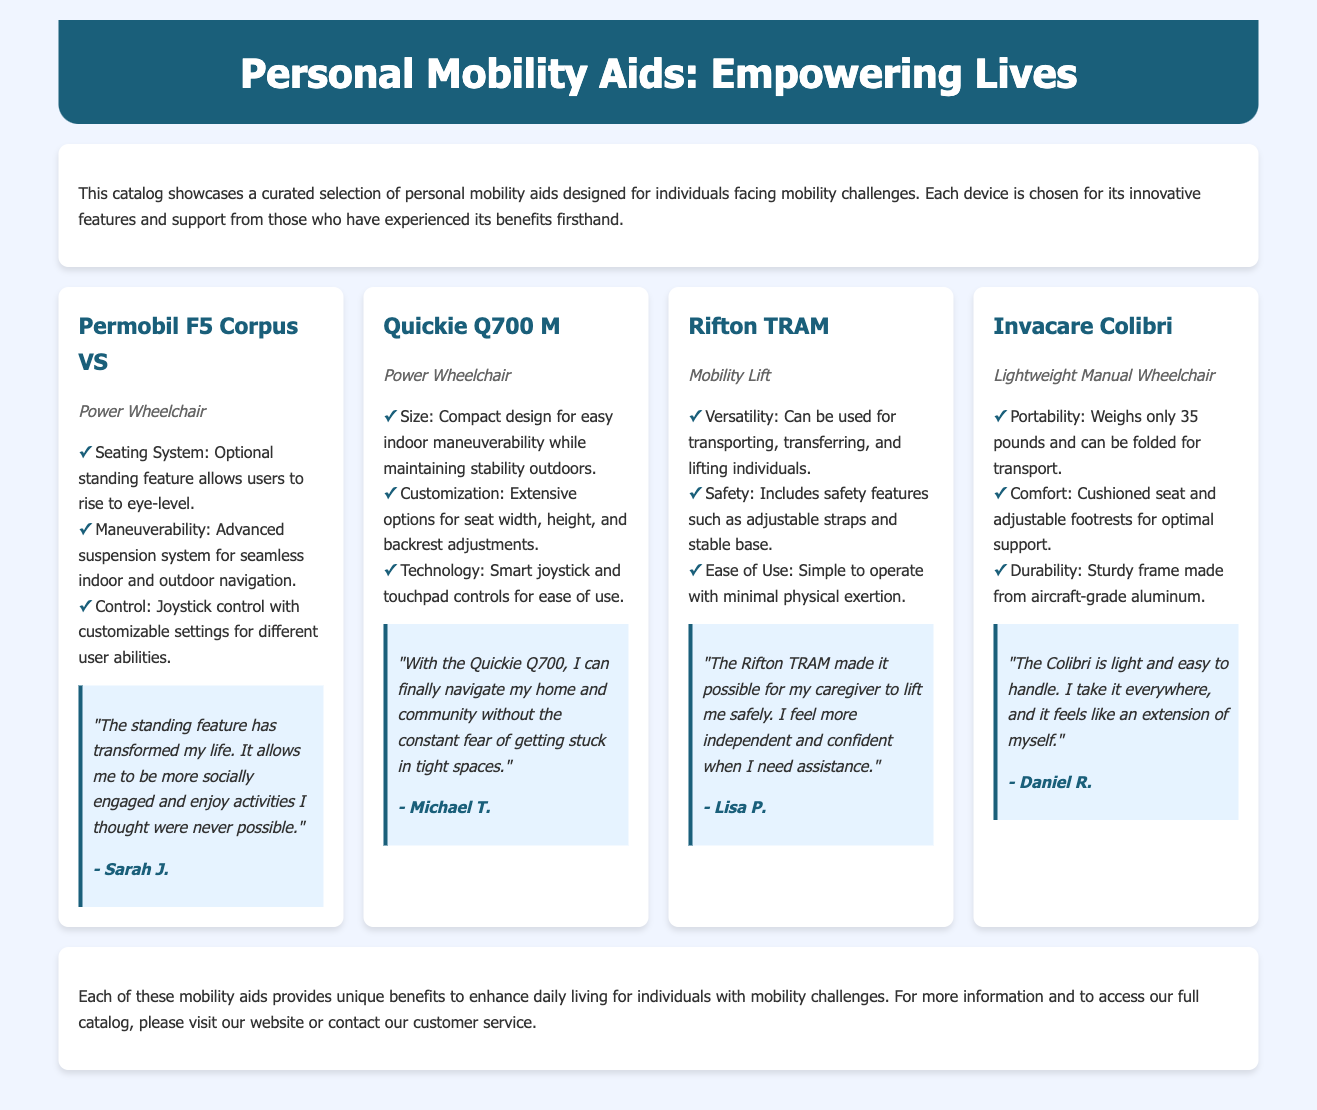what is the name of the first device showcased? The name of the first device listed in the document is "Permobil F5 Corpus VS."
Answer: Permobil F5 Corpus VS how many testimonials are included for the devices? There are four devices showcased, and each has one testimonial, totaling four testimonials.
Answer: 4 what is the weight of the Invacare Colibri? The Invacare Colibri is noted to weigh only 35 pounds, as stated in its description.
Answer: 35 pounds what feature does the Permobil F5 Corpus VS offer that allows users to engage socially? The standing feature allows users to rise to eye-level, enhancing social engagement.
Answer: standing feature who provided a testimonial for the Rifton TRAM? The user who provided a testimonial for the Rifton TRAM is identified as Lisa P.
Answer: Lisa P what type of mobility aid is the Rifton TRAM classified as? The Rifton TRAM is classified as a mobility lift as per the catalog.
Answer: Mobility Lift what material is the frame of the Invacare Colibri made from? The frame of the Invacare Colibri is made from aircraft-grade aluminum, as specified in the features.
Answer: aircraft-grade aluminum what is the primary function of the Quickie Q700 M? The primary function of the Quickie Q700 M is to serve as a power wheelchair for users requiring mobility assistance.
Answer: Power Wheelchair 